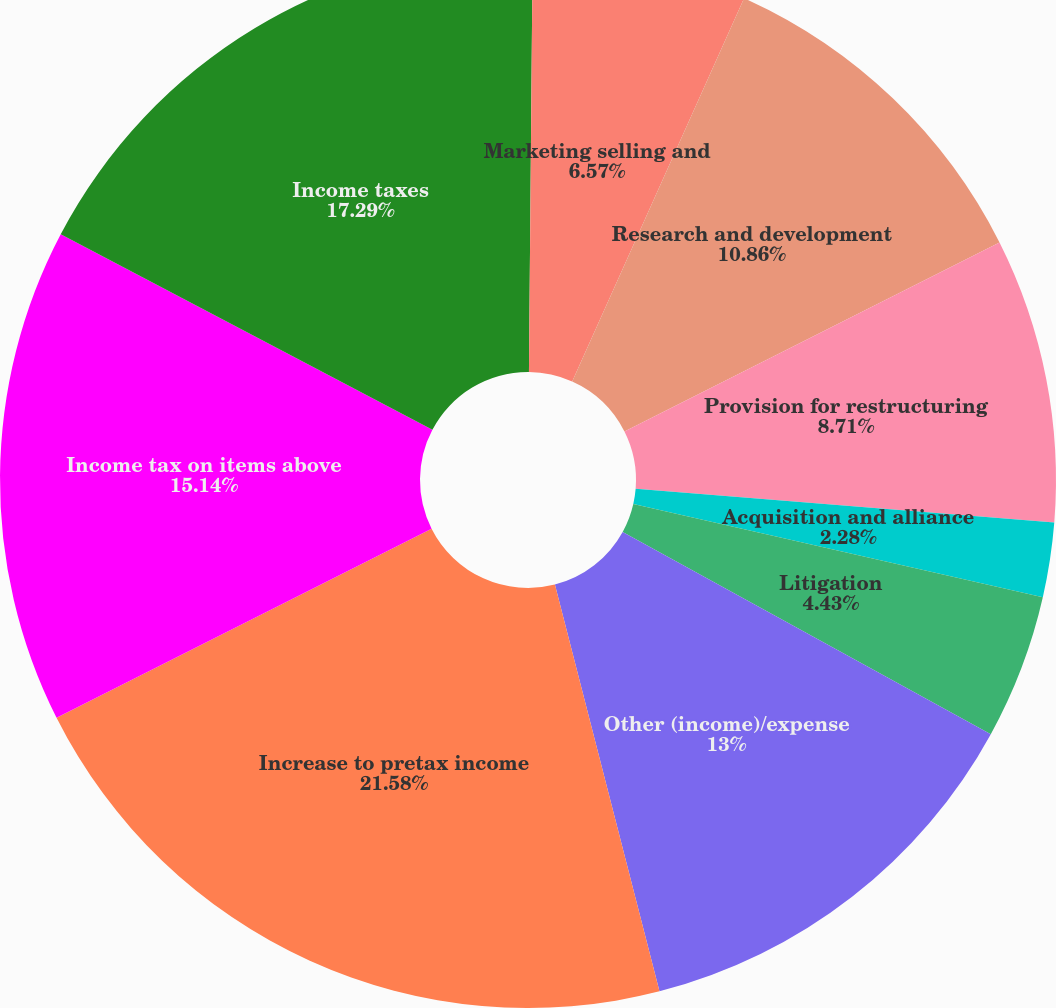Convert chart to OTSL. <chart><loc_0><loc_0><loc_500><loc_500><pie_chart><fcel>Process standardization<fcel>Marketing selling and<fcel>Research and development<fcel>Provision for restructuring<fcel>Acquisition and alliance<fcel>Litigation<fcel>Other (income)/expense<fcel>Increase to pretax income<fcel>Income tax on items above<fcel>Income taxes<nl><fcel>0.14%<fcel>6.57%<fcel>10.86%<fcel>8.71%<fcel>2.28%<fcel>4.43%<fcel>13.0%<fcel>21.57%<fcel>15.14%<fcel>17.29%<nl></chart> 